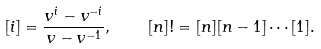Convert formula to latex. <formula><loc_0><loc_0><loc_500><loc_500>[ i ] = \frac { v ^ { i } - v ^ { - i } } { v - v ^ { - 1 } } , \quad [ n ] ! = [ n ] [ n - 1 ] \cdots [ 1 ] .</formula> 